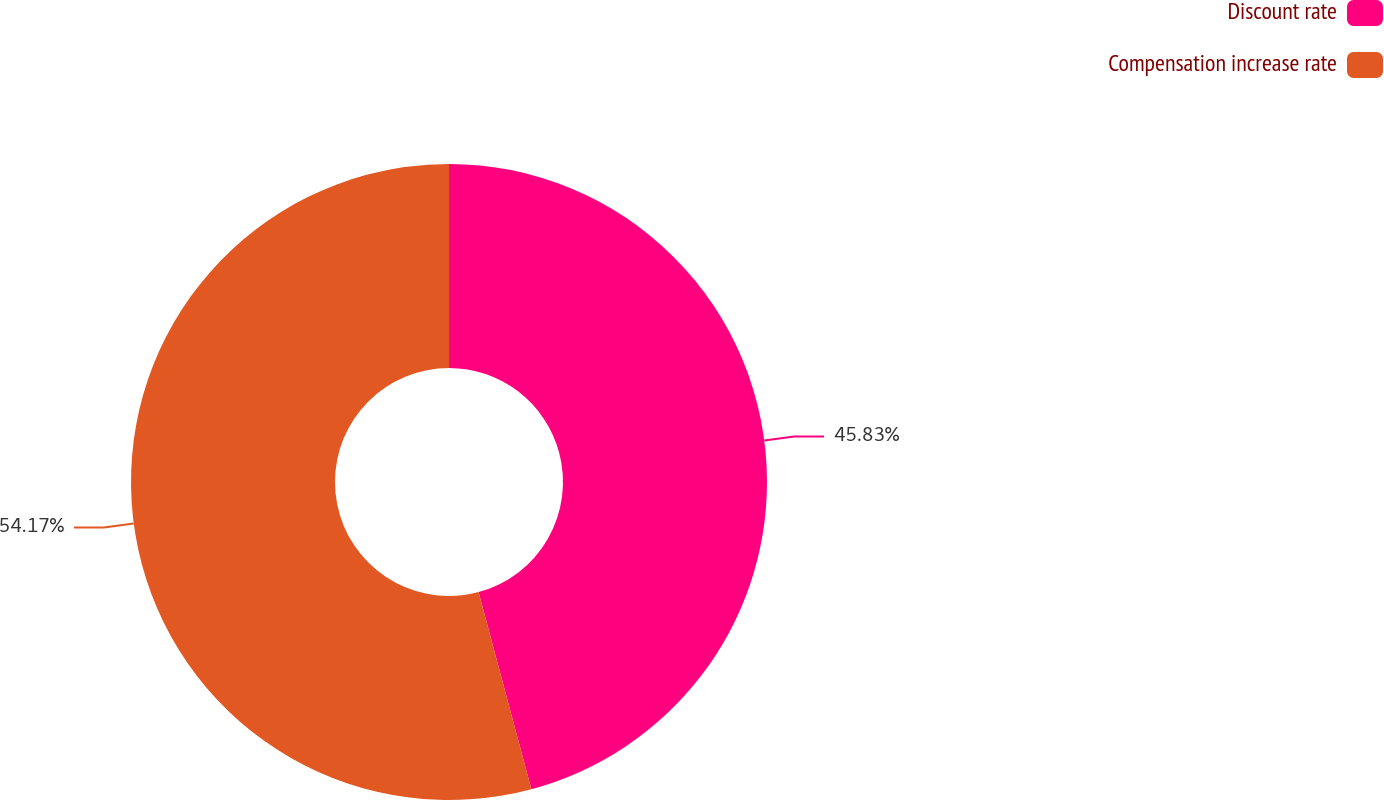Convert chart. <chart><loc_0><loc_0><loc_500><loc_500><pie_chart><fcel>Discount rate<fcel>Compensation increase rate<nl><fcel>45.83%<fcel>54.17%<nl></chart> 